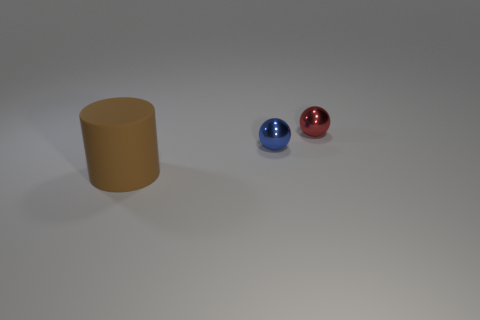Add 3 gray shiny blocks. How many objects exist? 6 Subtract all balls. How many objects are left? 1 Add 3 large brown rubber objects. How many large brown rubber objects are left? 4 Add 3 small objects. How many small objects exist? 5 Subtract 0 purple spheres. How many objects are left? 3 Subtract all large matte cylinders. Subtract all tiny blue spheres. How many objects are left? 1 